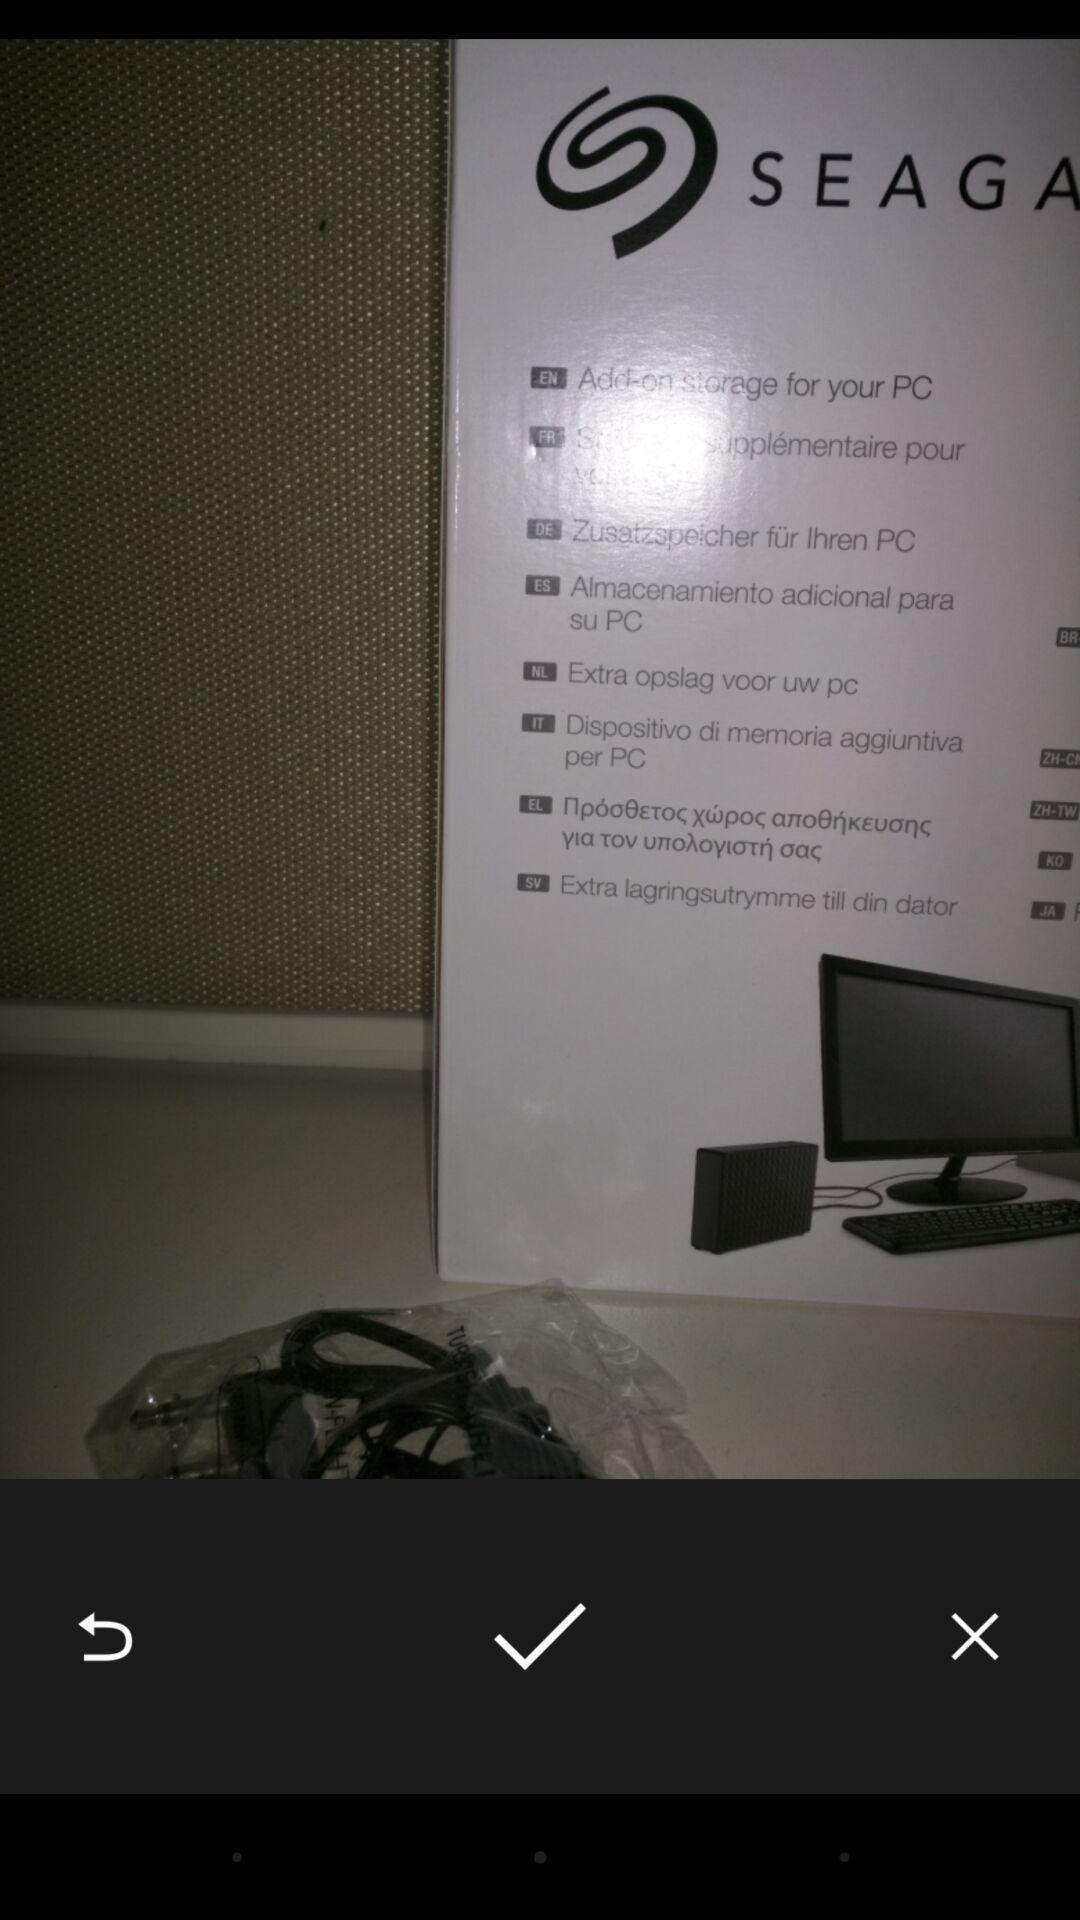Provide a detailed account of this screenshot. Screen displaying an image. 